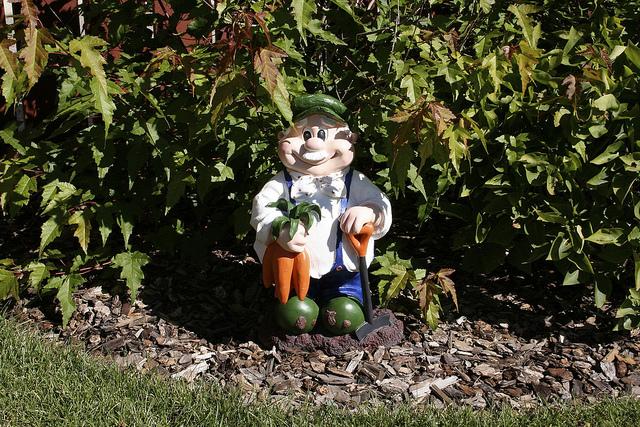What is this standing behind?
Keep it brief. Wood chips. What is this man holding in HIS right hand?
Give a very brief answer. Carrots. Is there grass in the photo?
Concise answer only. Yes. What color is his hat?
Quick response, please. Green. Is this a real person?
Short answer required. No. How many babies are pictured?
Quick response, please. 0. 